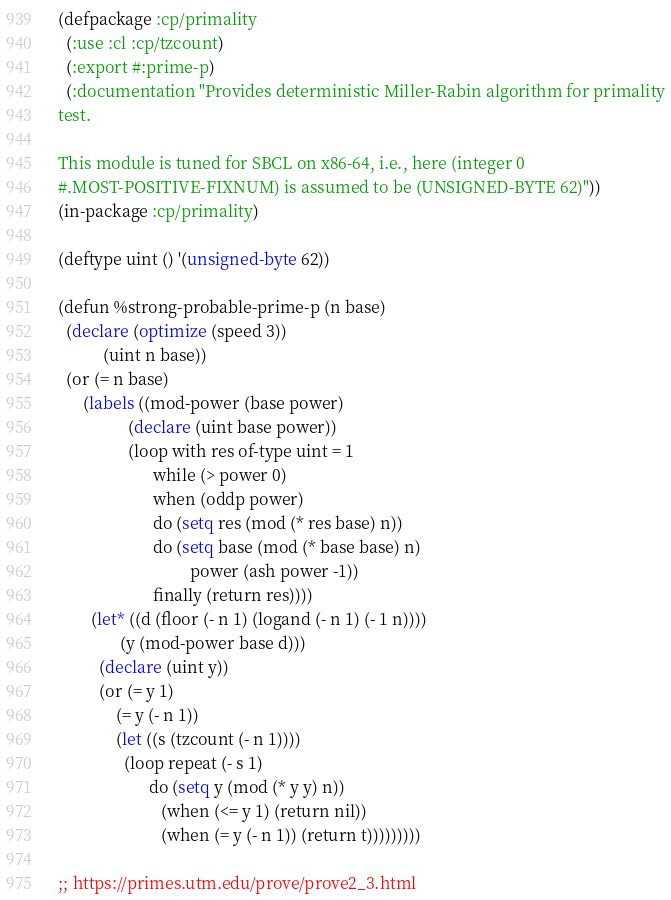<code> <loc_0><loc_0><loc_500><loc_500><_Lisp_>(defpackage :cp/primality
  (:use :cl :cp/tzcount)
  (:export #:prime-p)
  (:documentation "Provides deterministic Miller-Rabin algorithm for primality
test.

This module is tuned for SBCL on x86-64, i.e., here (integer 0
#.MOST-POSITIVE-FIXNUM) is assumed to be (UNSIGNED-BYTE 62)"))
(in-package :cp/primality)

(deftype uint () '(unsigned-byte 62))

(defun %strong-probable-prime-p (n base)
  (declare (optimize (speed 3))
           (uint n base))
  (or (= n base)
      (labels ((mod-power (base power)
                 (declare (uint base power))
                 (loop with res of-type uint = 1
                       while (> power 0)
                       when (oddp power)
                       do (setq res (mod (* res base) n))
                       do (setq base (mod (* base base) n)
                                power (ash power -1))
                       finally (return res))))
        (let* ((d (floor (- n 1) (logand (- n 1) (- 1 n))))
               (y (mod-power base d)))
          (declare (uint y))
          (or (= y 1)
              (= y (- n 1))
              (let ((s (tzcount (- n 1))))
                (loop repeat (- s 1)
                      do (setq y (mod (* y y) n))
                         (when (<= y 1) (return nil))
                         (when (= y (- n 1)) (return t)))))))))

;; https://primes.utm.edu/prove/prove2_3.html</code> 